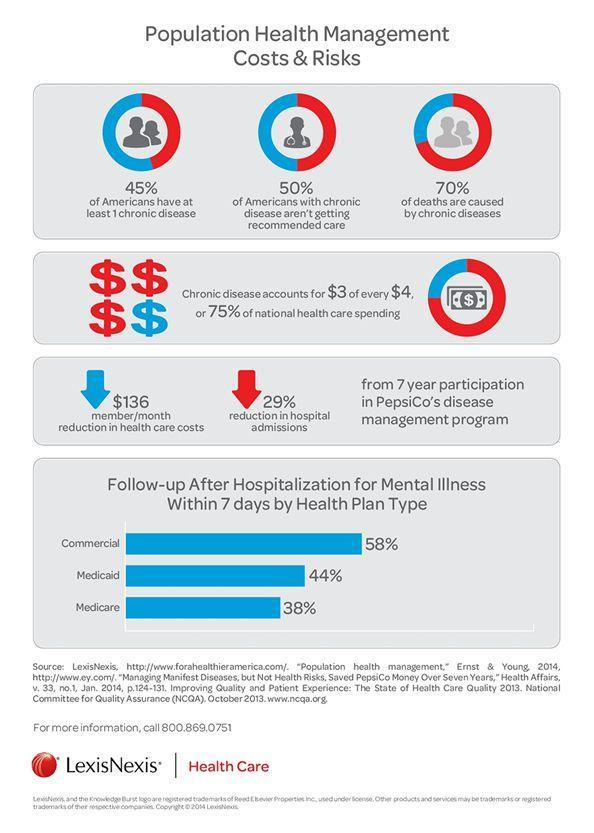What percentage of money spending is not for national health care?
Answer the question with a short phrase. 25% What percentage of Americans have at least one chronic disease? 45% What percentage of deaths are not caused by chronic diseases? 30% 